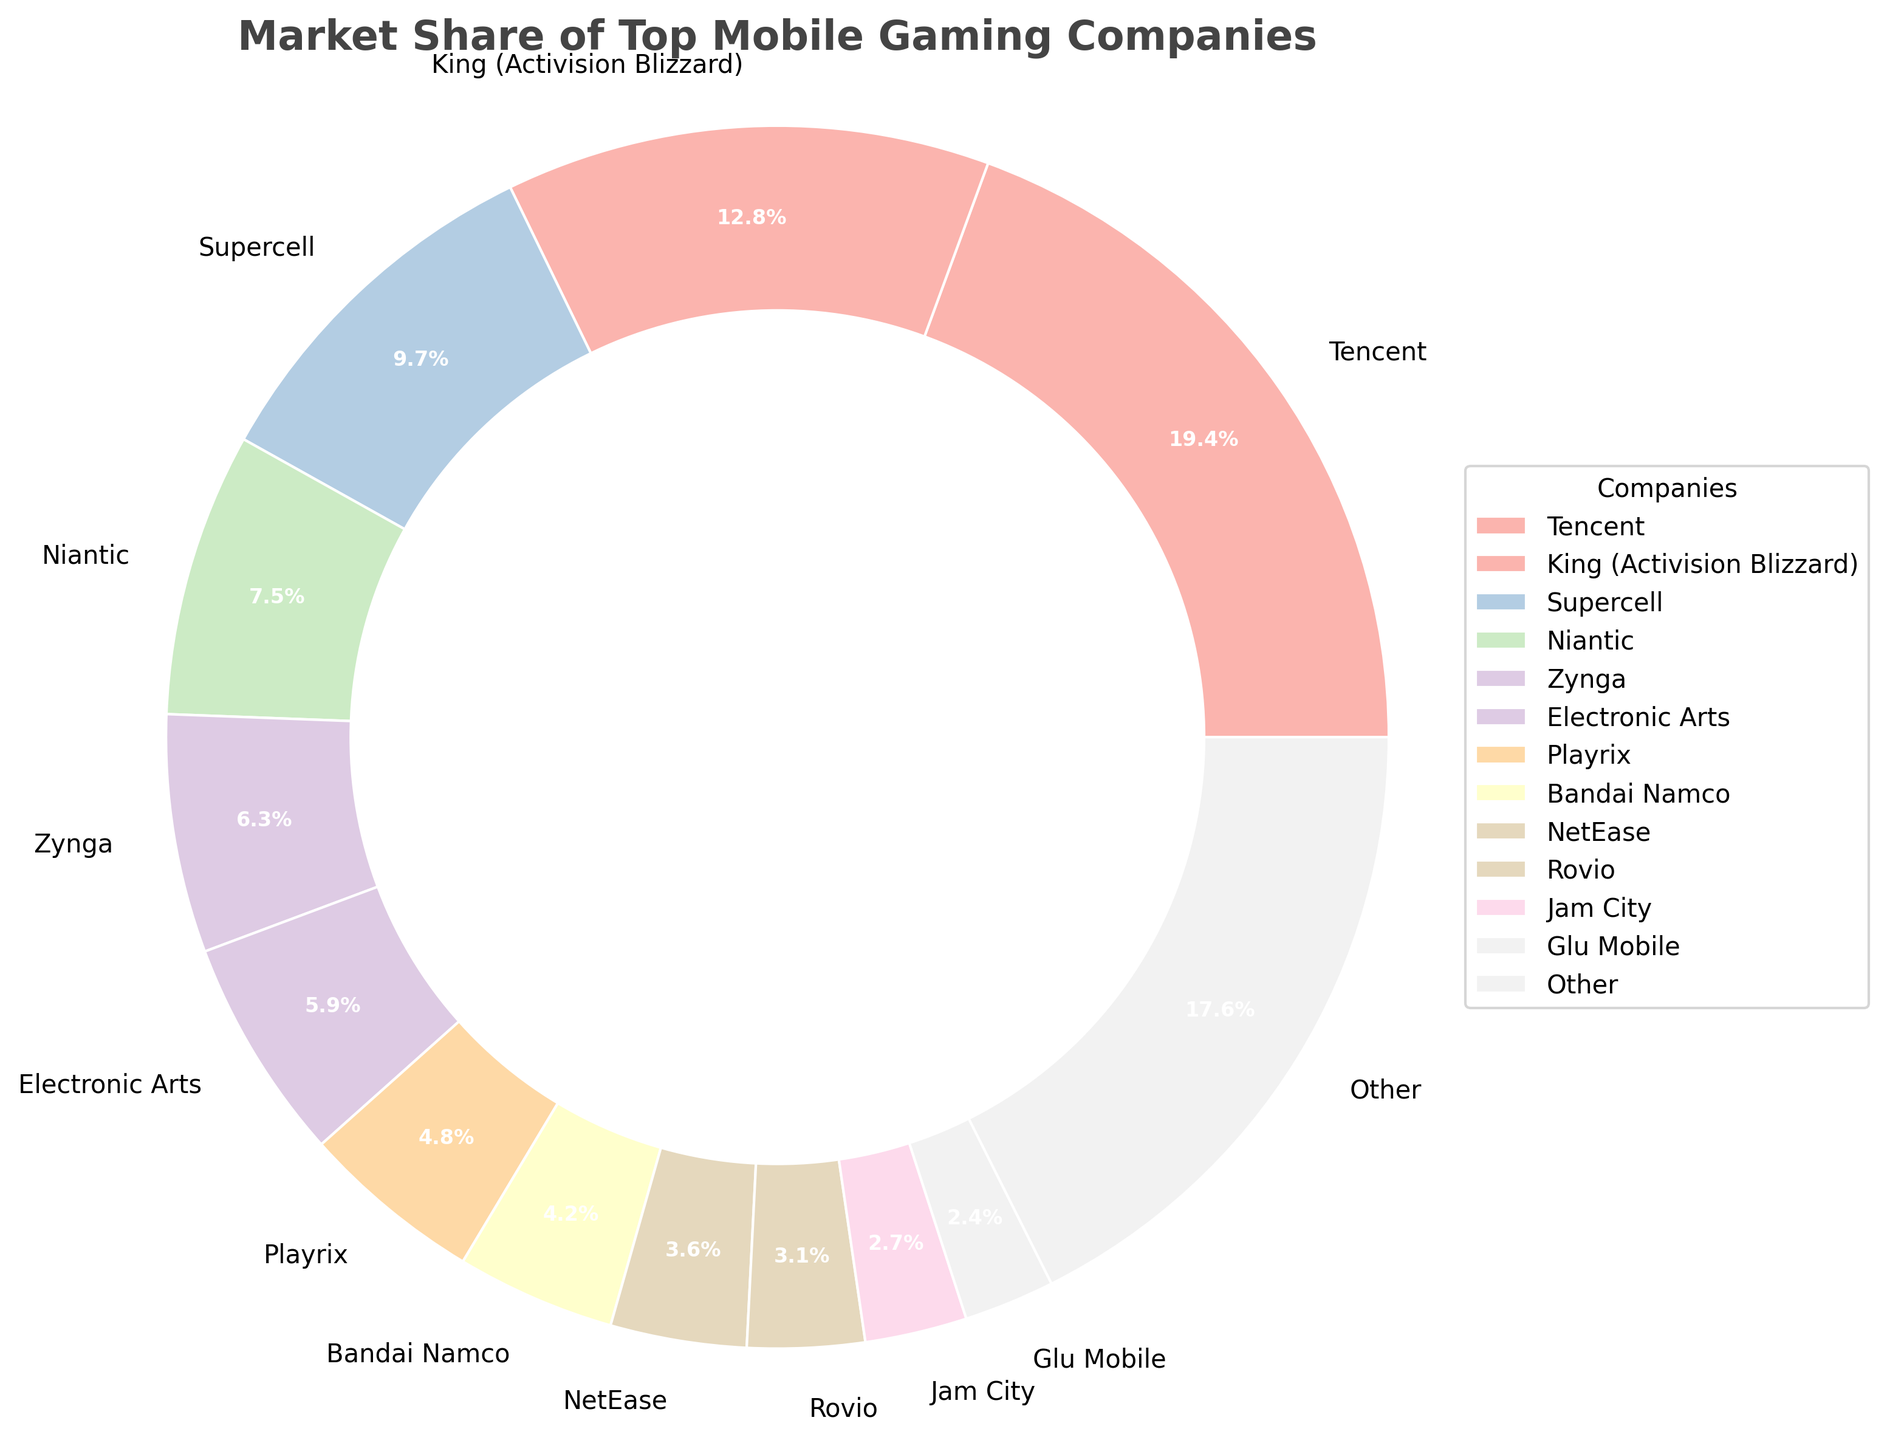What is the combined market share of Tencent and King (Activision Blizzard)? Tencent has a market share of 19.4%, and King (Activision Blizzard) has a market share of 12.8%. Adding these together gives 19.4 + 12.8 = 32.2.
Answer: 32.2% Which company has the smallest market share and what is it? Glu Mobile has the smallest market share of 2.4%, as seen on the chart.
Answer: Glu Mobile, 2.4% Which company has a larger market share, Niantic or Zynga? Niantic has a market share of 7.5%, while Zynga has a market share of 6.3%. Therefore, Niantic has a larger market share.
Answer: Niantic How much market share does the "Other" category represent? The "Other" category represents 17.6% of the market share, which is depicted in the pie chart.
Answer: 17.6% Compare the market shares of Supercell, Electronic Arts, and Bandai Namco. Which one is the largest? Supercell has a market share of 9.7%, Electronic Arts has 5.9%, and Bandai Namco has 4.2%. Therefore, Supercell has the largest market share among the three.
Answer: Supercell What is the total market share of companies with less than 5% each? The companies with less than 5% market share are Playrix, Bandai Namco, NetEase, Rovio, Jam City, and Glu Mobile. Their shares are 4.8%, 4.2%, 3.6%, 3.1%, 2.7%, and 2.4% respectively. Adding these together gives 4.8 + 4.2 + 3.6 + 3.1 + 2.7 + 2.4 = 20.8.
Answer: 20.8% How does Tencent's market share compare to the total market share of the bottom four companies? The bottom four companies are Rovio (3.1%), Jam City (2.7%), Glu Mobile (2.4%), and "Other" (17.6%). Their total market share is 3.1 + 2.7 + 2.4 + 17.6 = 25.8%. Tencent's share is 19.4%, which is less than the combined market share of these four.
Answer: Less than What is the difference in market share between Electronic Arts and Bandai Namco? Electronic Arts has a market share of 5.9%, and Bandai Namco has a market share of 4.2%. The difference between them is 5.9 - 4.2 = 1.7.
Answer: 1.7% What is the approximate percentage of market share covered by the top three companies? The top three companies are Tencent (19.4%), King (12.8%), and Supercell (9.7%). Adding these gives 19.4 + 12.8 + 9.7 = 41.9%.
Answer: 41.9% Which company has a market share close to 5%? Playrix has a market share of 4.8%, which is close to 5%.
Answer: Playrix 